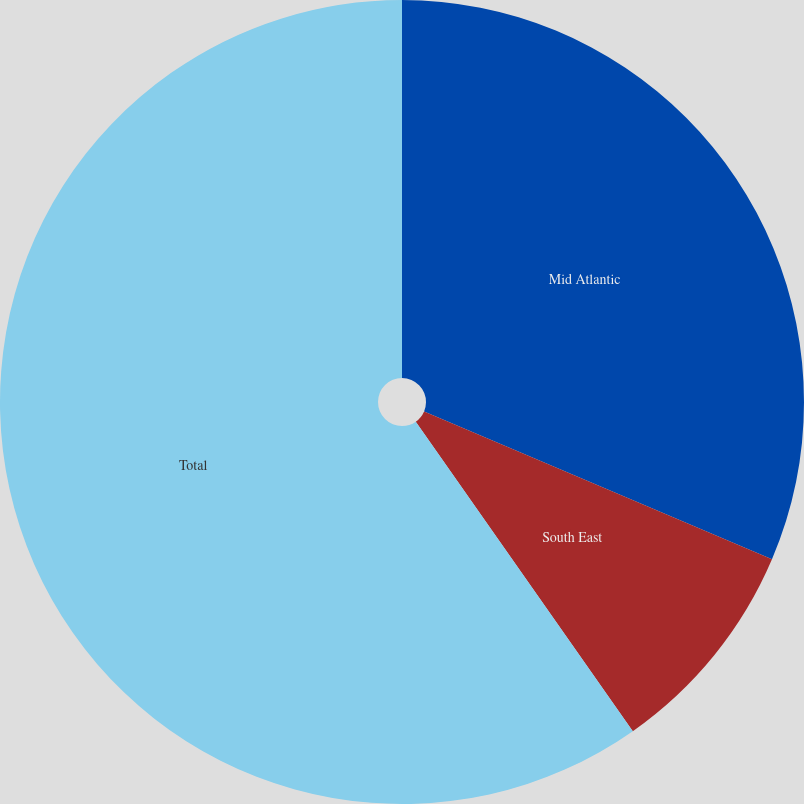<chart> <loc_0><loc_0><loc_500><loc_500><pie_chart><fcel>Mid Atlantic<fcel>South East<fcel>Total<nl><fcel>31.4%<fcel>8.87%<fcel>59.74%<nl></chart> 